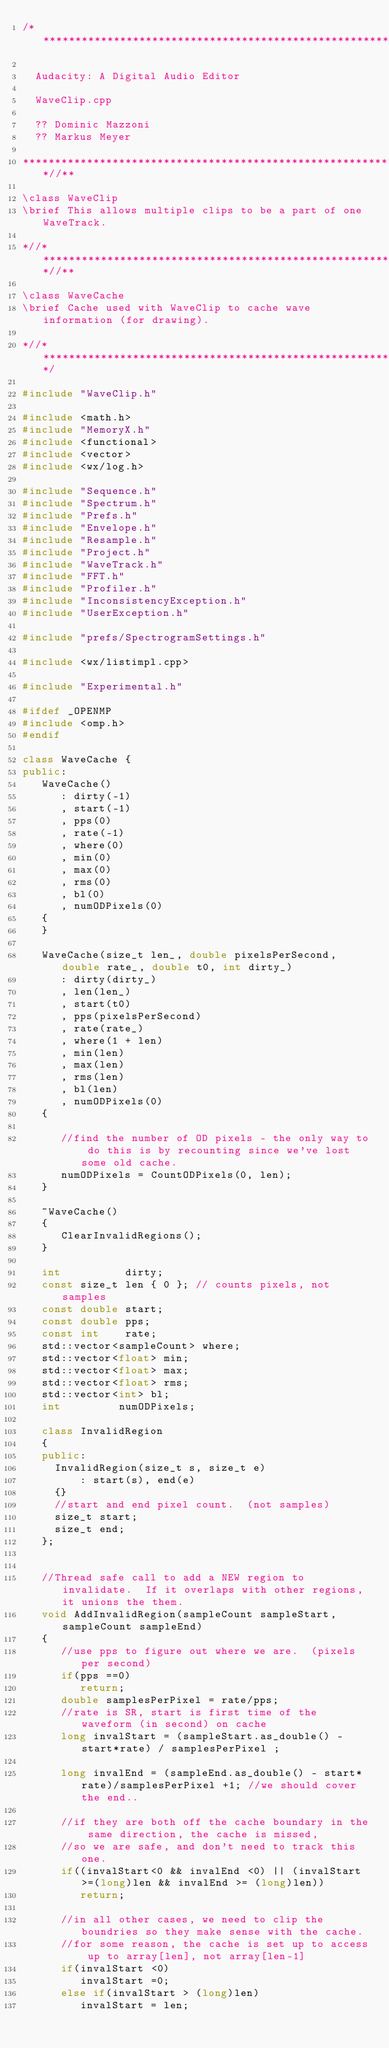Convert code to text. <code><loc_0><loc_0><loc_500><loc_500><_C++_>/**********************************************************************

  Audacity: A Digital Audio Editor

  WaveClip.cpp

  ?? Dominic Mazzoni
  ?? Markus Meyer

*******************************************************************//**

\class WaveClip
\brief This allows multiple clips to be a part of one WaveTrack.

*//****************************************************************//**

\class WaveCache
\brief Cache used with WaveClip to cache wave information (for drawing).

*//*******************************************************************/

#include "WaveClip.h"

#include <math.h>
#include "MemoryX.h"
#include <functional>
#include <vector>
#include <wx/log.h>

#include "Sequence.h"
#include "Spectrum.h"
#include "Prefs.h"
#include "Envelope.h"
#include "Resample.h"
#include "Project.h"
#include "WaveTrack.h"
#include "FFT.h"
#include "Profiler.h"
#include "InconsistencyException.h"
#include "UserException.h"

#include "prefs/SpectrogramSettings.h"

#include <wx/listimpl.cpp>

#include "Experimental.h"

#ifdef _OPENMP
#include <omp.h>
#endif

class WaveCache {
public:
   WaveCache()
      : dirty(-1)
      , start(-1)
      , pps(0)
      , rate(-1)
      , where(0)
      , min(0)
      , max(0)
      , rms(0)
      , bl(0)
      , numODPixels(0)
   {
   }

   WaveCache(size_t len_, double pixelsPerSecond, double rate_, double t0, int dirty_)
      : dirty(dirty_)
      , len(len_)
      , start(t0)
      , pps(pixelsPerSecond)
      , rate(rate_)
      , where(1 + len)
      , min(len)
      , max(len)
      , rms(len)
      , bl(len)
      , numODPixels(0)
   {

      //find the number of OD pixels - the only way to do this is by recounting since we've lost some old cache.
      numODPixels = CountODPixels(0, len);
   }

   ~WaveCache()
   {
      ClearInvalidRegions();
   }

   int          dirty;
   const size_t len { 0 }; // counts pixels, not samples
   const double start;
   const double pps;
   const int    rate;
   std::vector<sampleCount> where;
   std::vector<float> min;
   std::vector<float> max;
   std::vector<float> rms;
   std::vector<int> bl;
   int         numODPixels;

   class InvalidRegion
   {
   public:
     InvalidRegion(size_t s, size_t e)
         : start(s), end(e)
     {}
     //start and end pixel count.  (not samples)
     size_t start;
     size_t end;
   };


   //Thread safe call to add a NEW region to invalidate.  If it overlaps with other regions, it unions the them.
   void AddInvalidRegion(sampleCount sampleStart, sampleCount sampleEnd)
   {
      //use pps to figure out where we are.  (pixels per second)
      if(pps ==0)
         return;
      double samplesPerPixel = rate/pps;
      //rate is SR, start is first time of the waveform (in second) on cache
      long invalStart = (sampleStart.as_double() - start*rate) / samplesPerPixel ;

      long invalEnd = (sampleEnd.as_double() - start*rate)/samplesPerPixel +1; //we should cover the end..

      //if they are both off the cache boundary in the same direction, the cache is missed,
      //so we are safe, and don't need to track this one.
      if((invalStart<0 && invalEnd <0) || (invalStart>=(long)len && invalEnd >= (long)len))
         return;

      //in all other cases, we need to clip the boundries so they make sense with the cache.
      //for some reason, the cache is set up to access up to array[len], not array[len-1]
      if(invalStart <0)
         invalStart =0;
      else if(invalStart > (long)len)
         invalStart = len;
</code> 